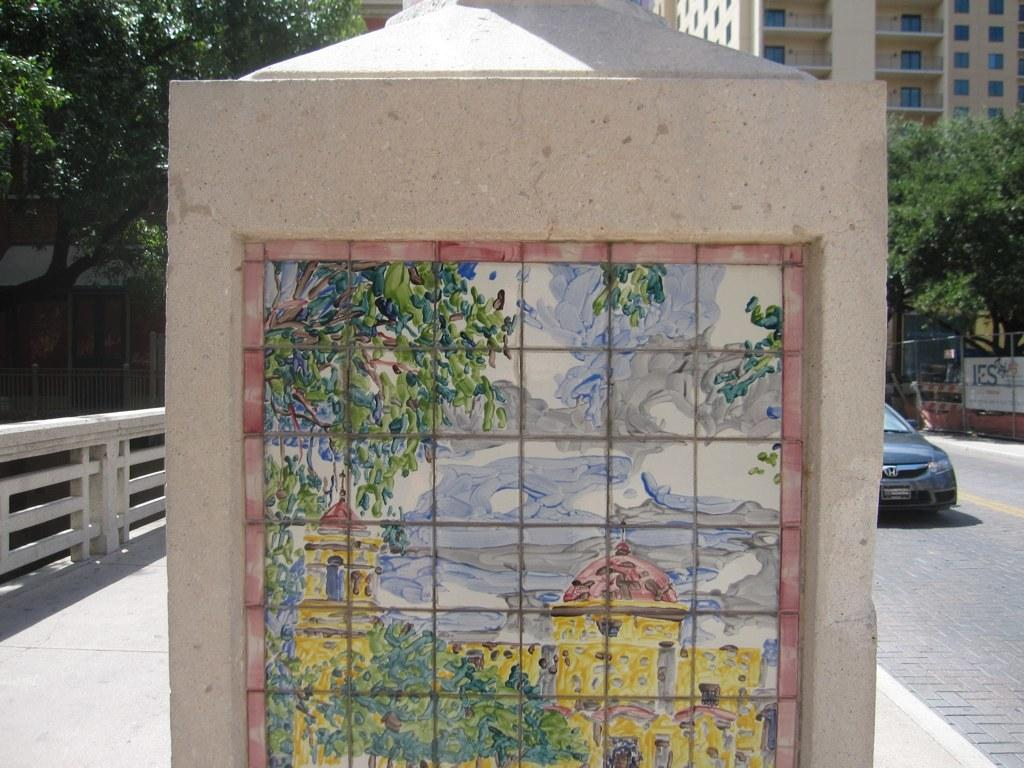What is hanging on the wall in the image? There is a painting on the wall in the image. What can be seen in the background of the image? There is a road visible in the image. What is the vehicle in the image used for? The specific use of the vehicle cannot be determined from the image. What is the board in the image used for? The purpose of the board in the image cannot be determined from the image. What type of barrier is present in the image? There is a fence in the image. What type of vegetation is present in the image? Trees are present in the image. What type of structure is visible in the image? There is a building in the image. Can you hear the sound of the cough in the image? There is no sound or indication of a cough in the image. What type of party is being held in the image? There is no party or indication of a party in the image. 